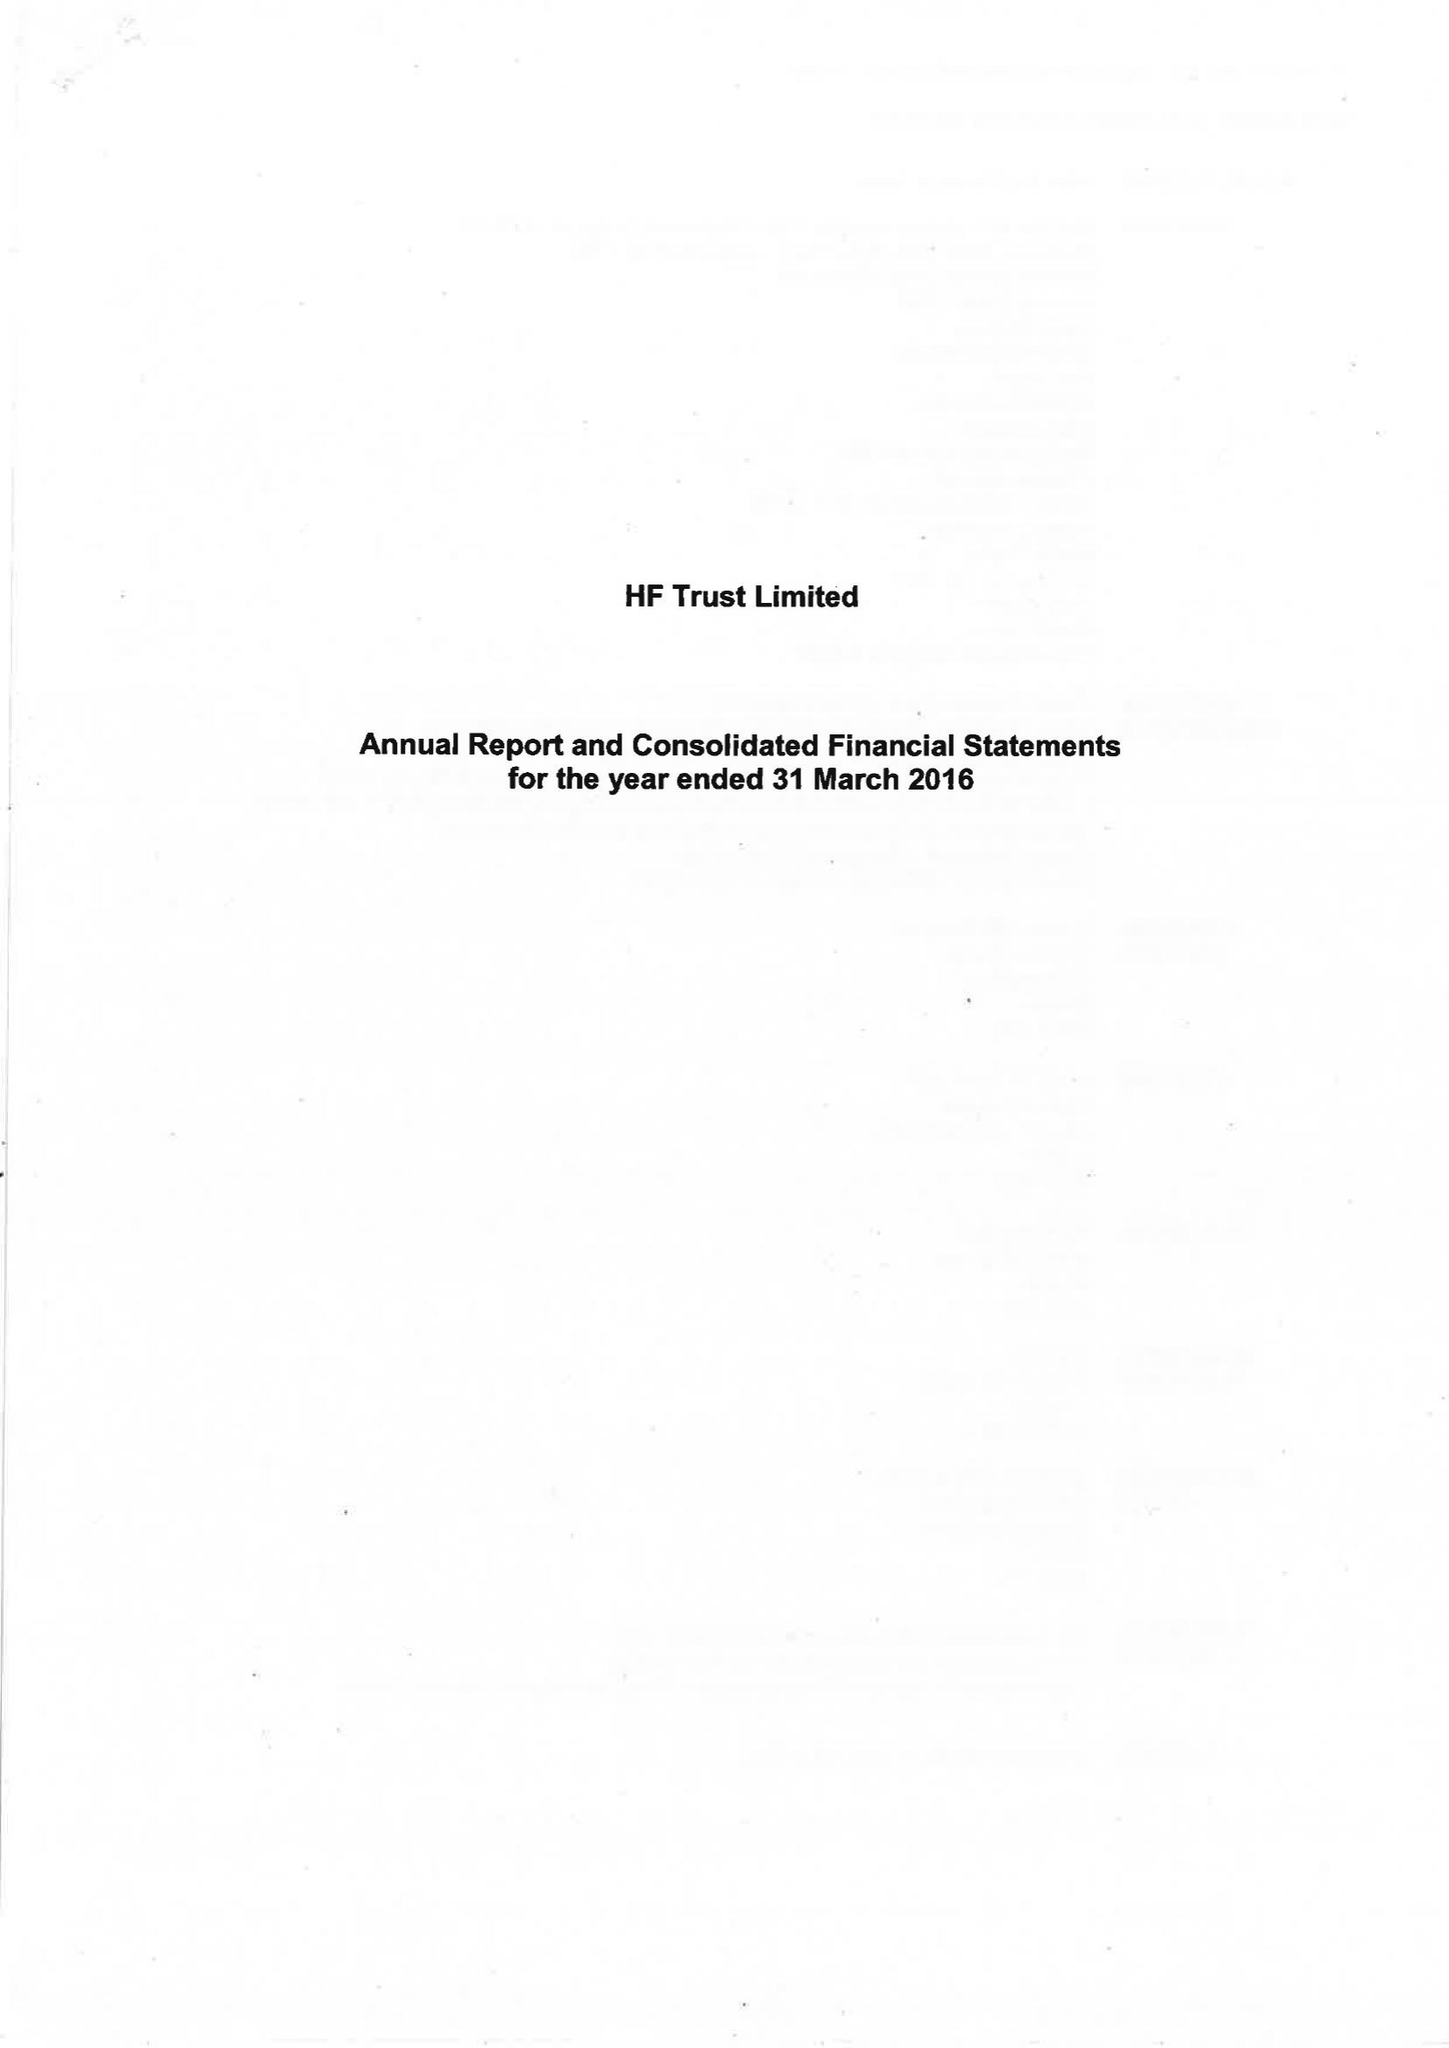What is the value for the address__post_town?
Answer the question using a single word or phrase. BRISTOL 